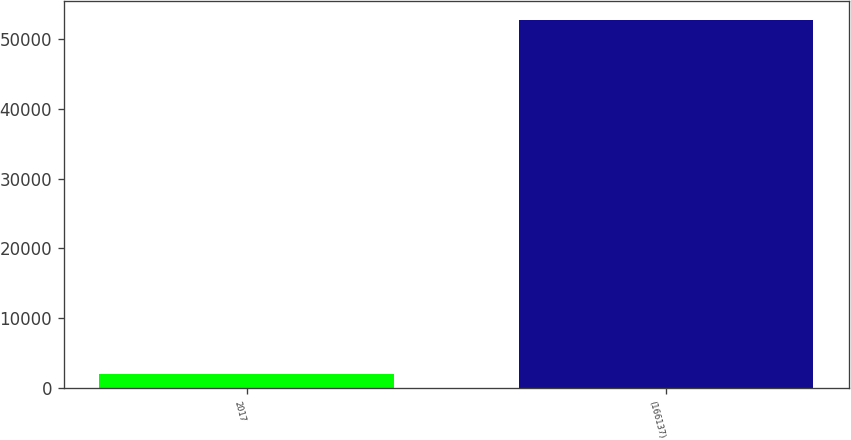Convert chart. <chart><loc_0><loc_0><loc_500><loc_500><bar_chart><fcel>2017<fcel>(166137)<nl><fcel>2015<fcel>52742<nl></chart> 